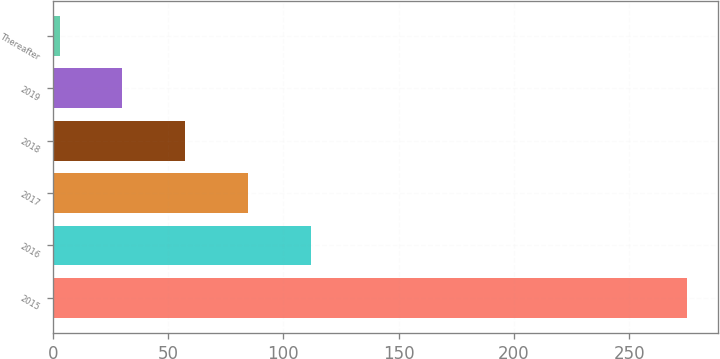Convert chart to OTSL. <chart><loc_0><loc_0><loc_500><loc_500><bar_chart><fcel>2015<fcel>2016<fcel>2017<fcel>2018<fcel>2019<fcel>Thereafter<nl><fcel>275<fcel>111.8<fcel>84.6<fcel>57.4<fcel>30.2<fcel>3<nl></chart> 